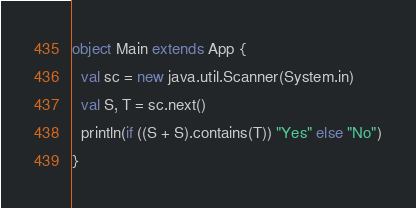Convert code to text. <code><loc_0><loc_0><loc_500><loc_500><_Scala_>object Main extends App {
  val sc = new java.util.Scanner(System.in)
  val S, T = sc.next()
  println(if ((S + S).contains(T)) "Yes" else "No")
}
</code> 